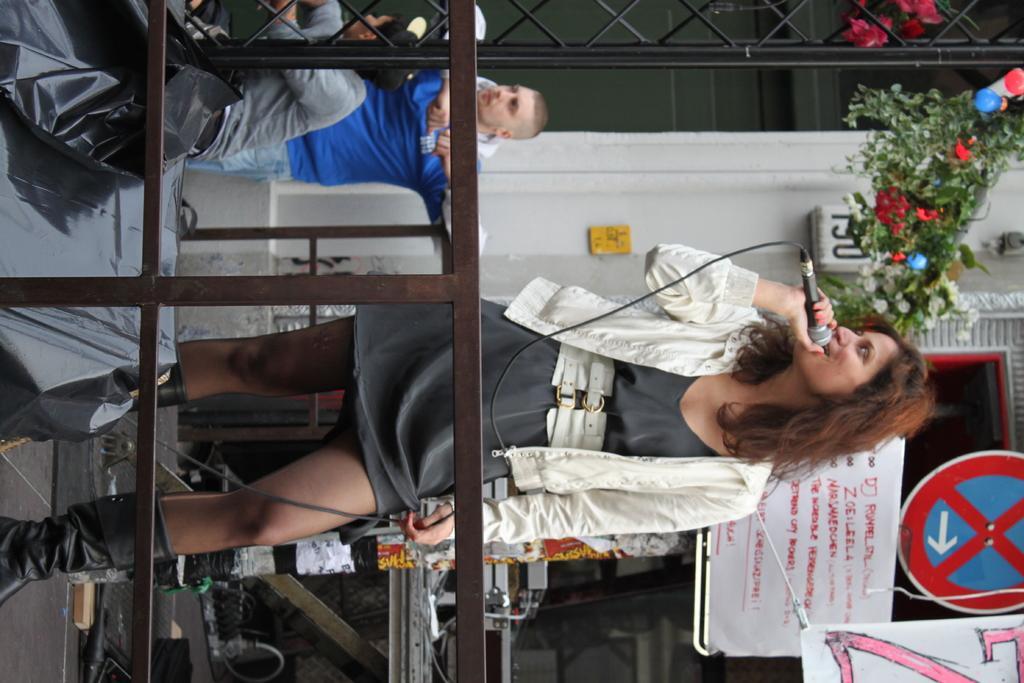Describe this image in one or two sentences. This picture is in right side direction. In this image there is a woman standing and holding the microphone and there are two people. At the back there is a building and there are boards and there are plants and there is a pole. In the foreground there is a railing. At the back there are objects. In the foreground it looks like a speaker. 